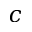Convert formula to latex. <formula><loc_0><loc_0><loc_500><loc_500>c</formula> 